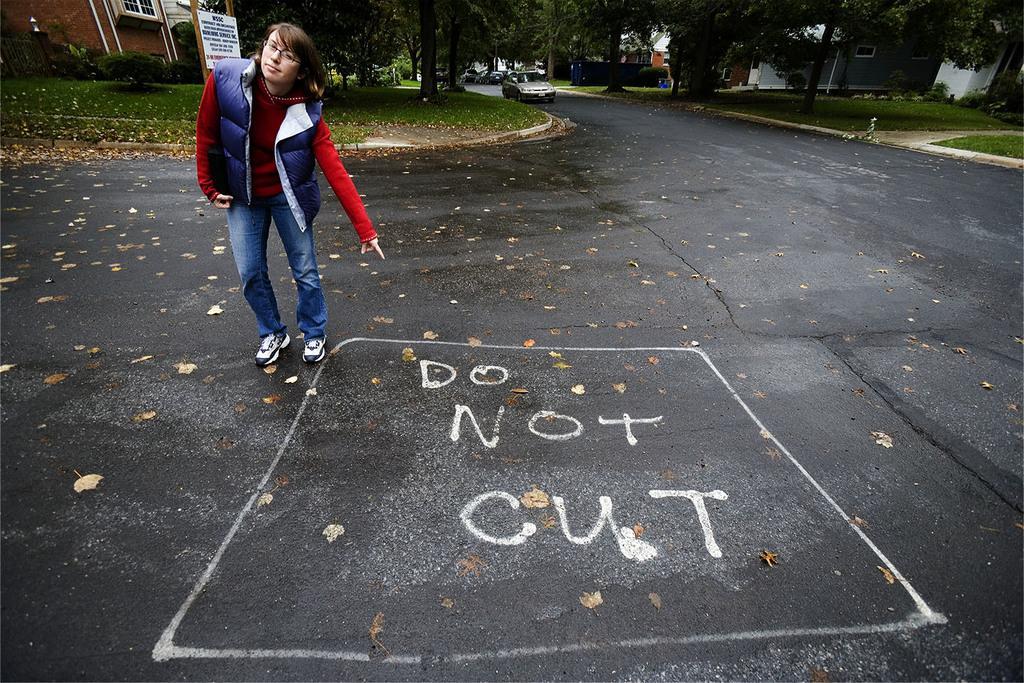Describe this image in one or two sentences. In this image there is a road, On the road there are cars and a person standing and pointing towards to "do not cut" paint. And besides that there are buildings, Trees, Signboard and a fence. 